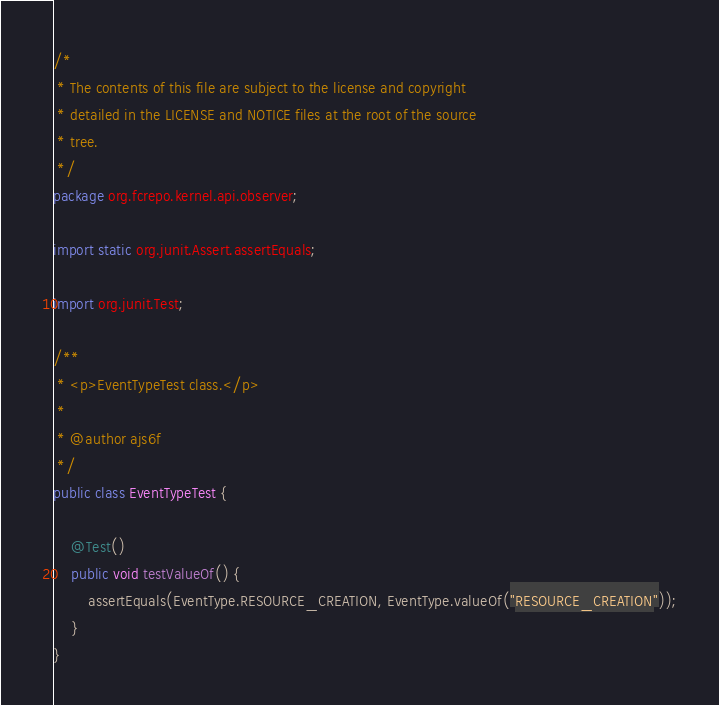Convert code to text. <code><loc_0><loc_0><loc_500><loc_500><_Java_>/*
 * The contents of this file are subject to the license and copyright
 * detailed in the LICENSE and NOTICE files at the root of the source
 * tree.
 */
package org.fcrepo.kernel.api.observer;

import static org.junit.Assert.assertEquals;

import org.junit.Test;

/**
 * <p>EventTypeTest class.</p>
 *
 * @author ajs6f
 */
public class EventTypeTest {

    @Test()
    public void testValueOf() {
        assertEquals(EventType.RESOURCE_CREATION, EventType.valueOf("RESOURCE_CREATION"));
    }
}
</code> 